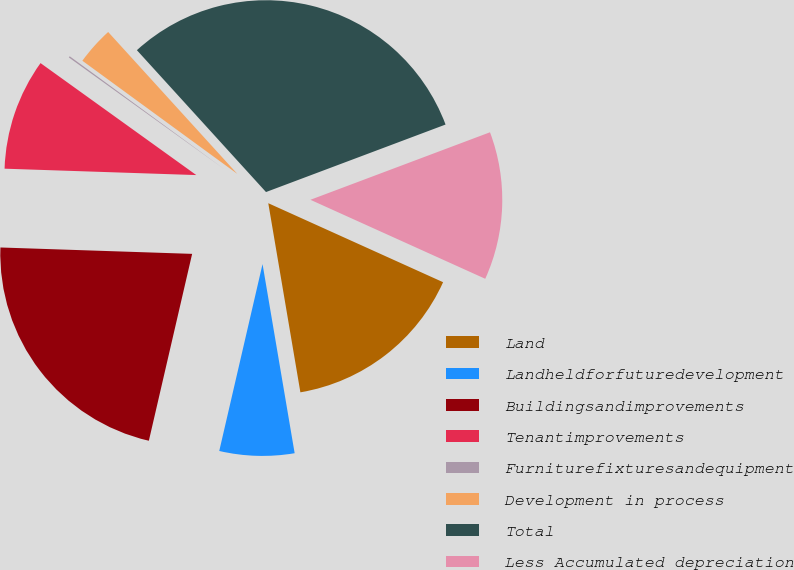<chart> <loc_0><loc_0><loc_500><loc_500><pie_chart><fcel>Land<fcel>Landheldforfuturedevelopment<fcel>Buildingsandimprovements<fcel>Tenantimprovements<fcel>Furniturefixturesandequipment<fcel>Development in process<fcel>Total<fcel>Less Accumulated depreciation<nl><fcel>15.57%<fcel>6.3%<fcel>21.91%<fcel>9.39%<fcel>0.12%<fcel>3.21%<fcel>31.03%<fcel>12.48%<nl></chart> 